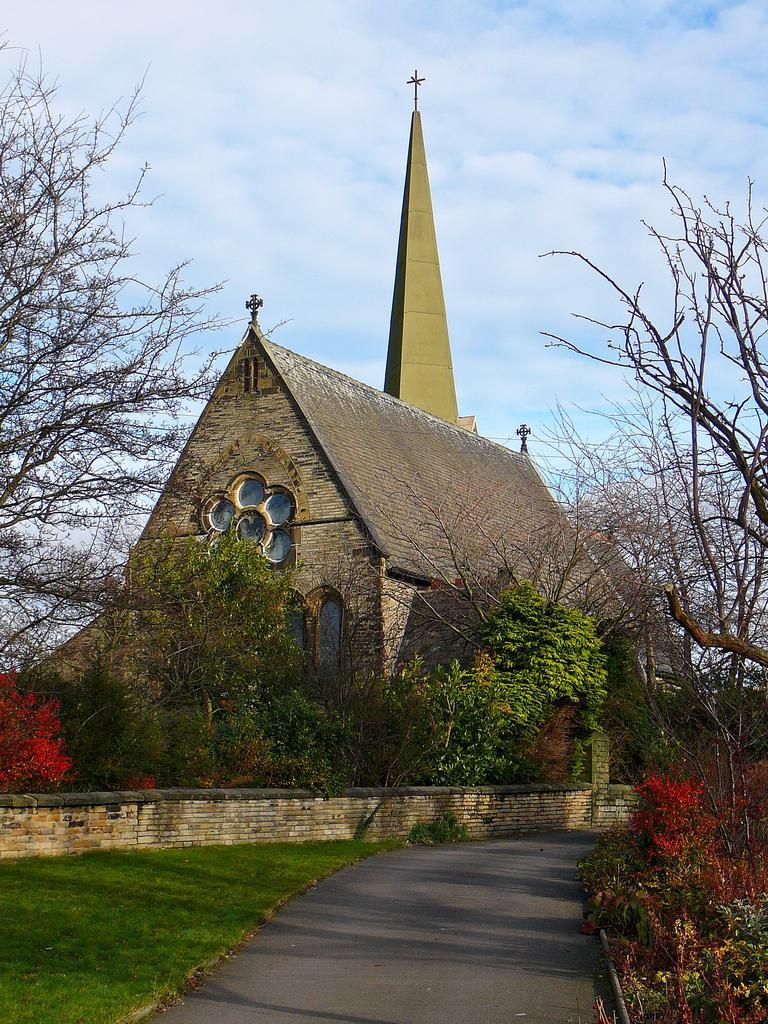Please provide a concise description of this image. In this image we can see some houses, at the top we can see some cross symbols, there are some plants, trees, road, grass and the wall, in the background we can see the sky with clouds. 